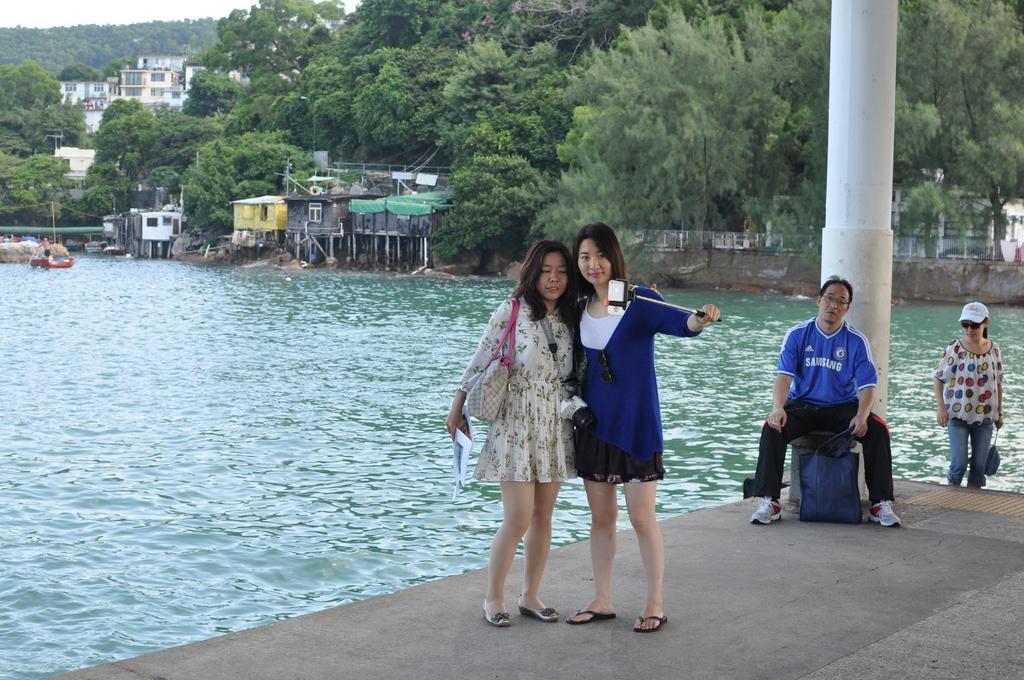Can you describe this image briefly? In this image I can see group of people. In front I can see the person standing and holding some object and I can also see the bag in white color. In the background I can see the water, few buildings, trees in green color and the sky is in white color. 